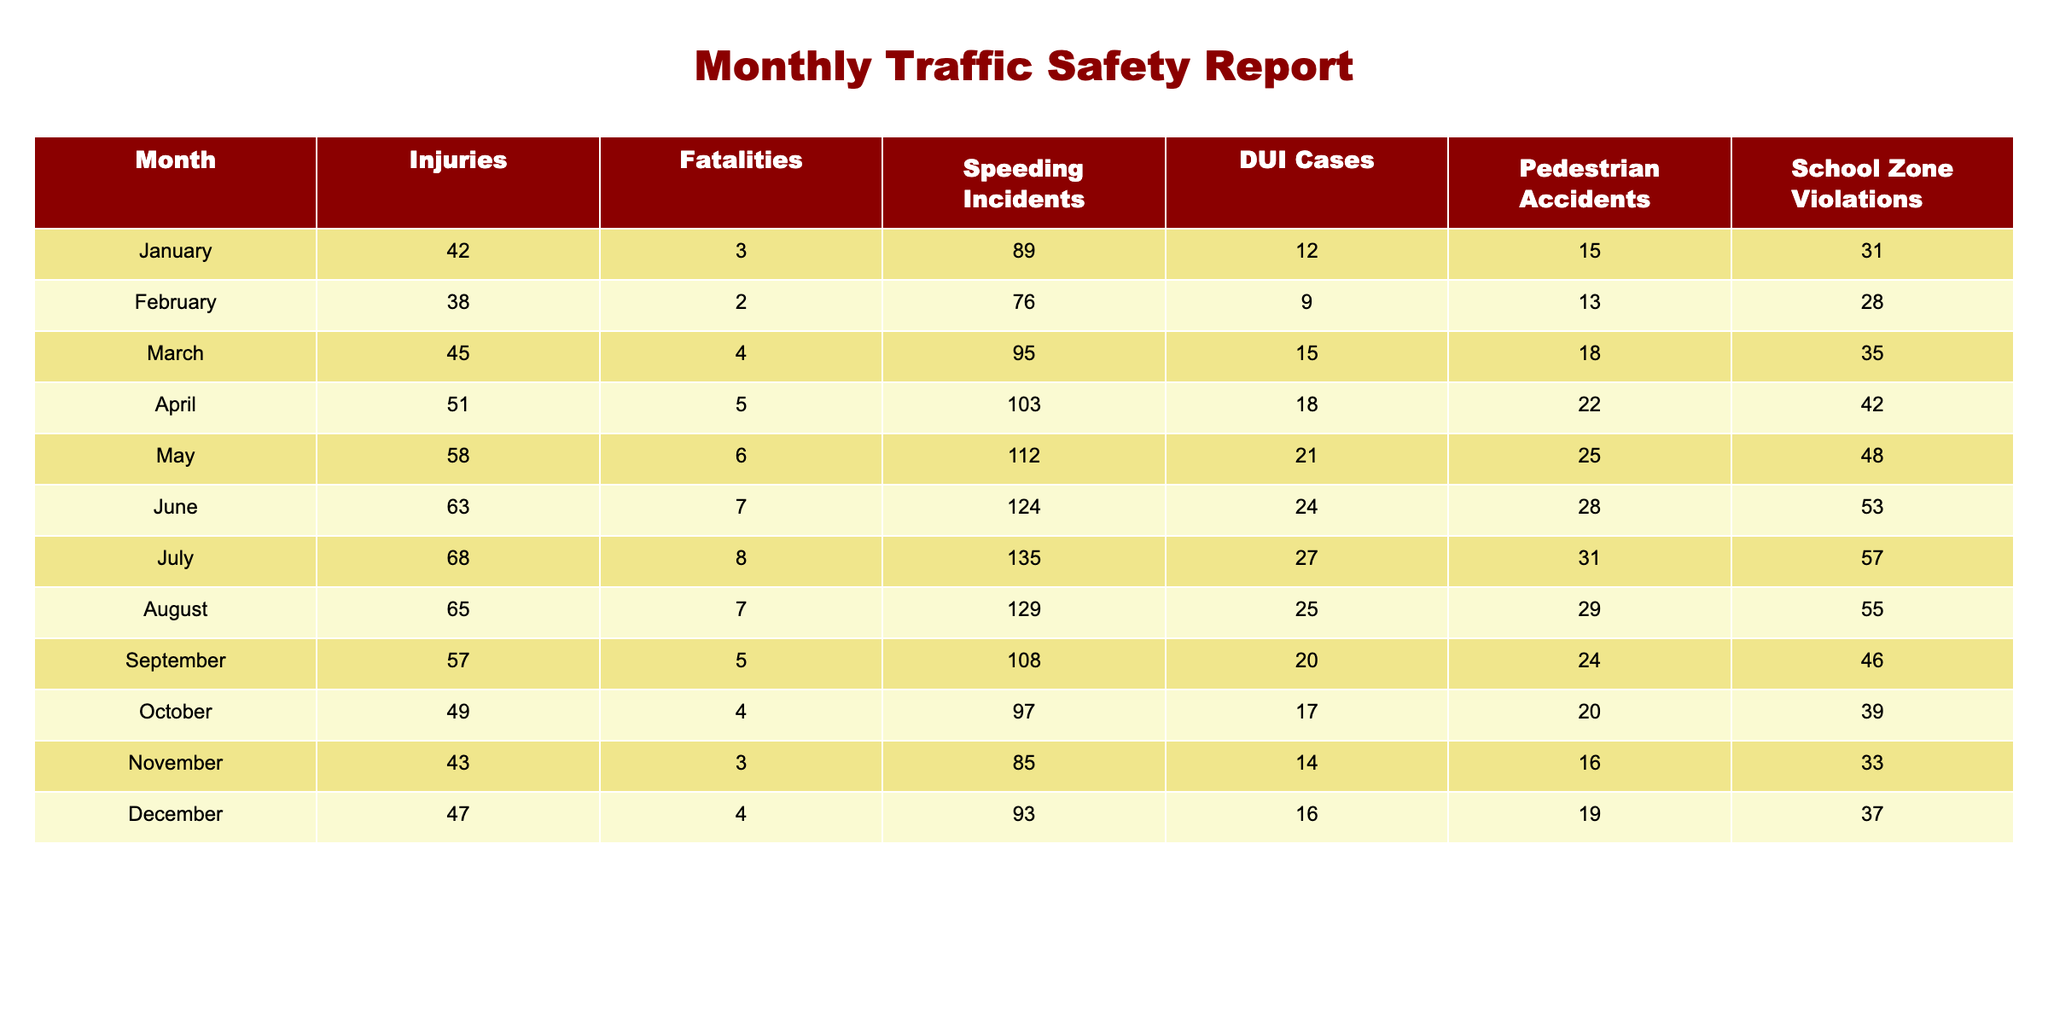What was the number of fatalities in July? From the table, locate the row for July and read the corresponding value under the Fatalities column, which shows 8.
Answer: 8 In which month were the highest number of pedestrian accidents reported? Scanning through the Pedestrian Accidents column, January has 15 accidents, while other months have lower numbers. Therefore, January has the highest.
Answer: January How many total injuries occurred in the first half of the year (January to June)? Add the values in the Injuries column from January to June: 42 + 38 + 45 + 51 + 58 + 63 = 297.
Answer: 297 Is it true that there were more fatalities than DUI cases in any month? Compare the Fatalities and DUI Cases columns; in every month, the number of DUI cases is either equal to or higher than the fatalities. Thus, the statement is true.
Answer: Yes What is the average number of speeding incidents over the entire year? To find the average, sum all speeding incidents: 89 + 76 + 95 + 103 + 112 + 124 + 135 + 129 + 108 + 97 + 85 + 93 = 1,579. Then divide by 12 months: 1,579 / 12 = approximately 131.58.
Answer: 132 Which month had the lowest number of school zone violations, and how many were there? Check the School Zone Violations column; the month with the lowest count is February, which had 28 violations.
Answer: February, 28 What is the difference between the total fatalities in the first and last quarter of the year? First quarter fatalities (January to March) total 3 + 2 + 4 = 9. Last quarter fatalities (October to December) total 4 + 3 + 4 = 11. The difference is 11 - 9 = 2.
Answer: 2 Which month experienced the most injuries, and what was that count? The highest value in the Injuries column is 68 for the month of July.
Answer: July, 68 Calculate the median number of DUI cases for the year. To find the median, list the DUI cases in order: 9, 12, 14, 15, 16, 17, 18, 21, 24, 27, 18, 24. There are 12 items, so the median is the average of the 6th and 7th values: (17 + 18) / 2 = 17.5.
Answer: 17.5 How many months reported fatalities of more than 4? Reviewing the Fatalities column, the months with more than 4 fatalities are April, May, June, July (5 months).
Answer: 5 